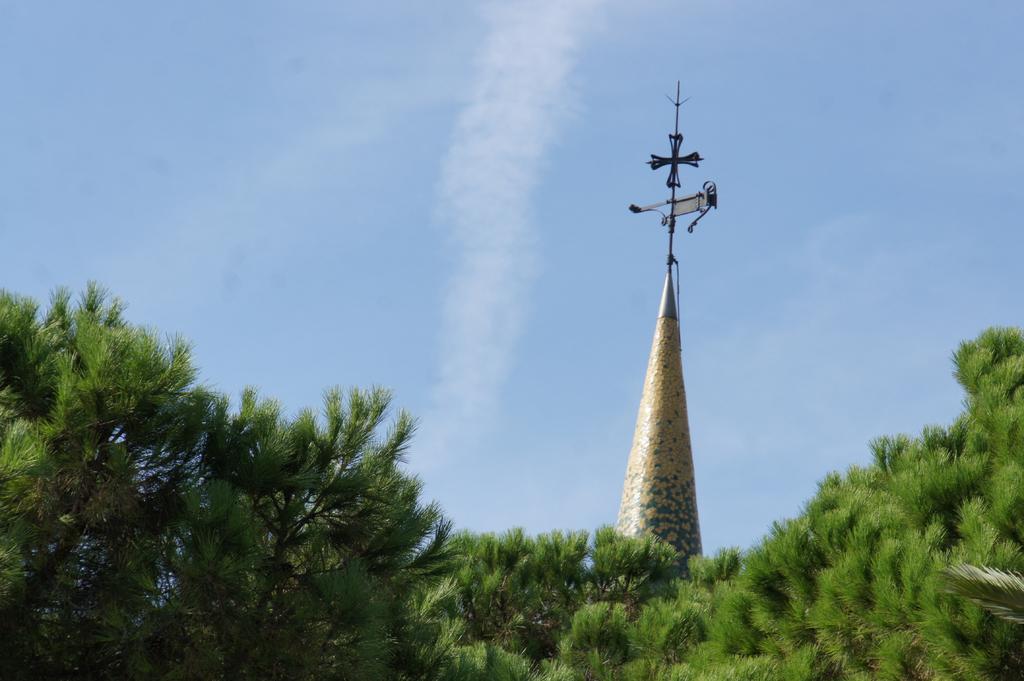In one or two sentences, can you explain what this image depicts? In the image we can see there are lot of trees. Behind there is a tower of the building and there is a clear sky on the top. 